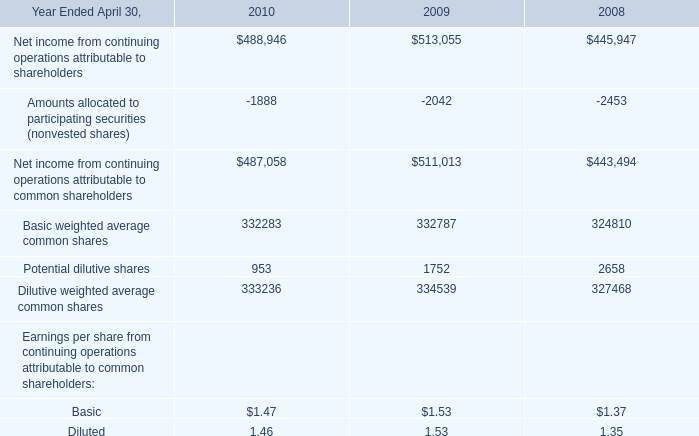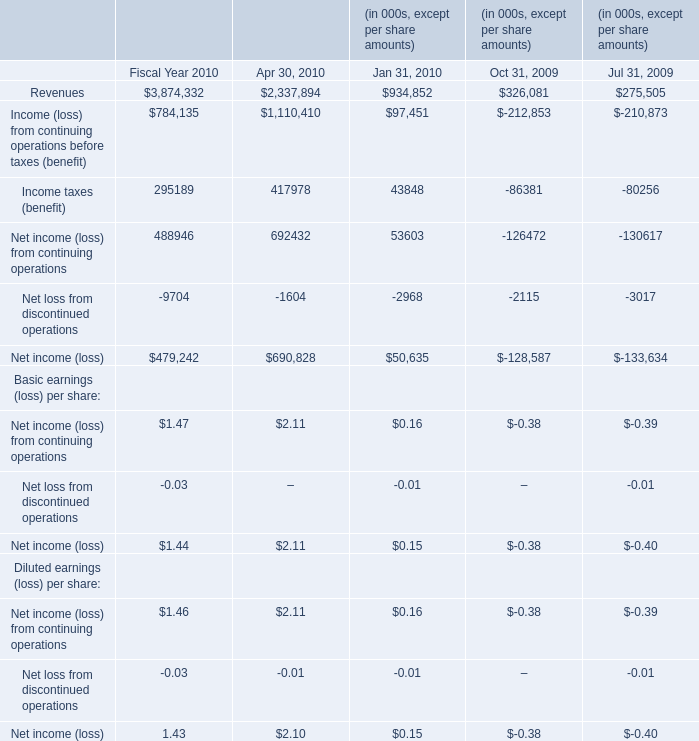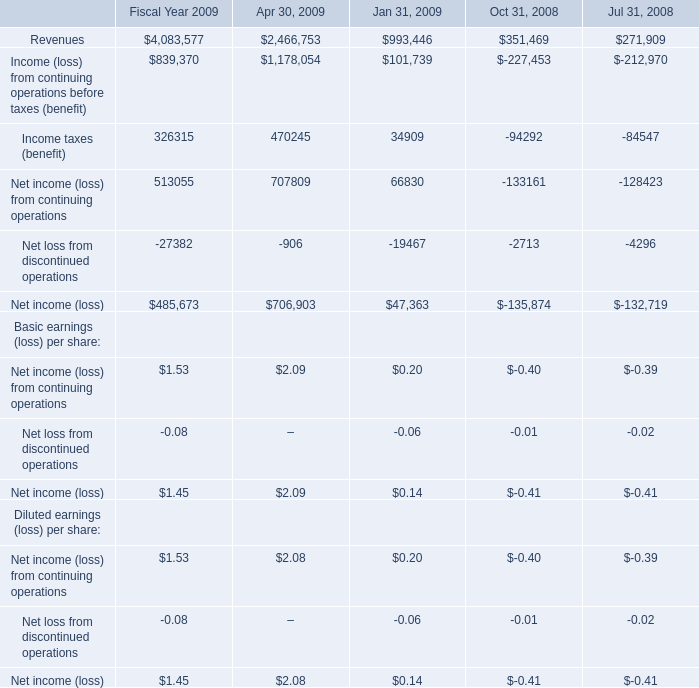What is the 60% of the highest Net income for Basic earnings (loss) per share in the chart? 
Computations: (0.6 * 2.09)
Answer: 1.254. 